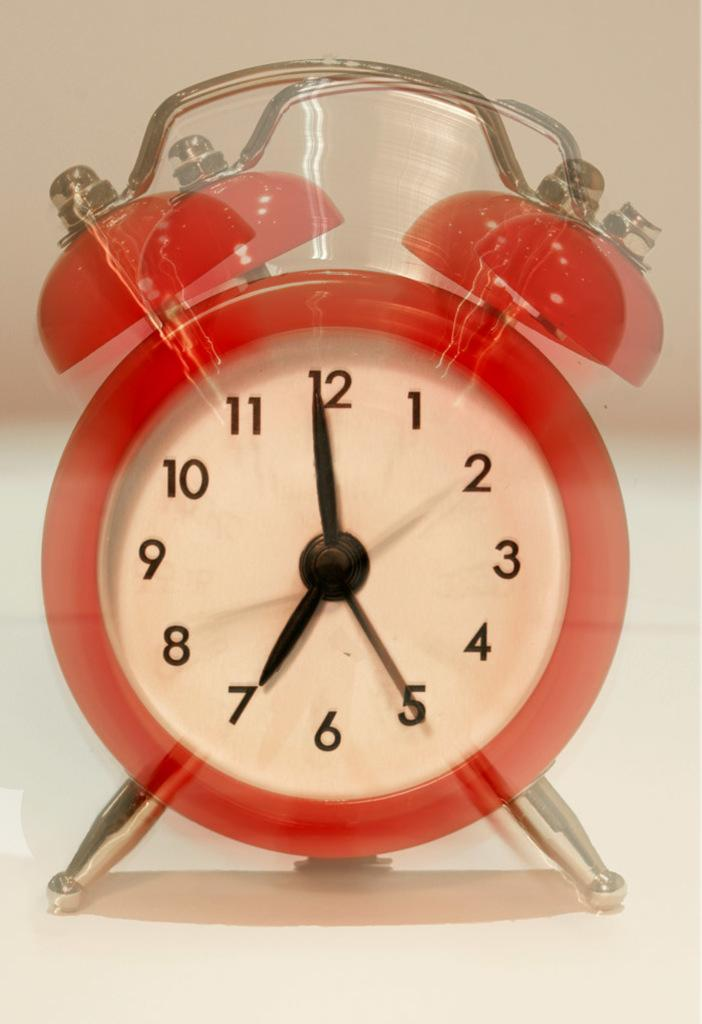<image>
Describe the image concisely. A red alarm clock with a white face and black numbers reads 6:58. 